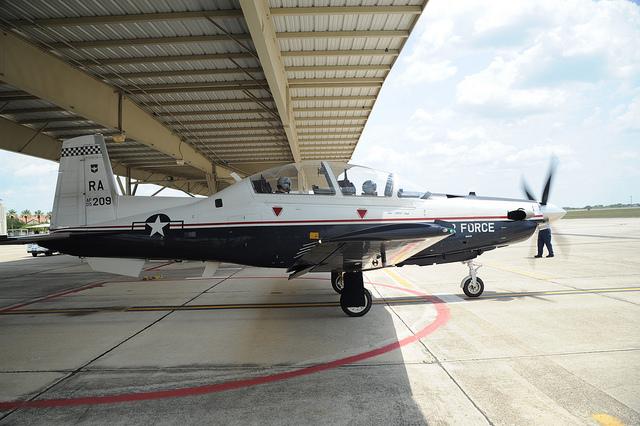How many stars are on the plane?
Short answer required. 1. What word is on the front?
Be succinct. Force. What color is the plane?
Short answer required. White and black. 